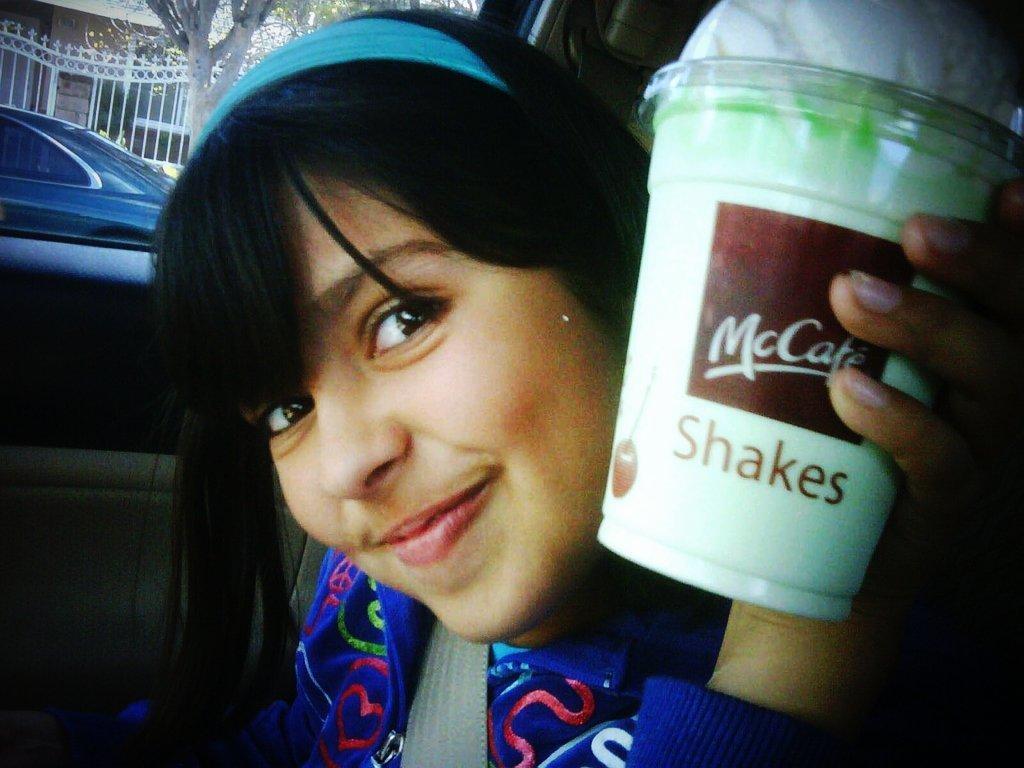Describe this image in one or two sentences. in this image we can see a woman smiling and holding a disposal tumblr in her hand. In the background there are trees, grills, building and a motor vehicle. 